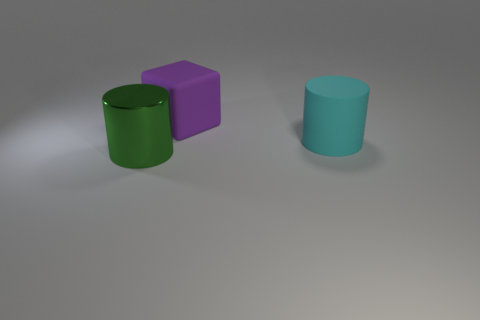Add 1 small gray things. How many objects exist? 4 Subtract all brown cylinders. Subtract all yellow blocks. How many cylinders are left? 2 Subtract all cylinders. How many objects are left? 1 Add 3 big brown metal blocks. How many big brown metal blocks exist? 3 Subtract 0 red cylinders. How many objects are left? 3 Subtract all large green cylinders. Subtract all shiny objects. How many objects are left? 1 Add 1 big green metal cylinders. How many big green metal cylinders are left? 2 